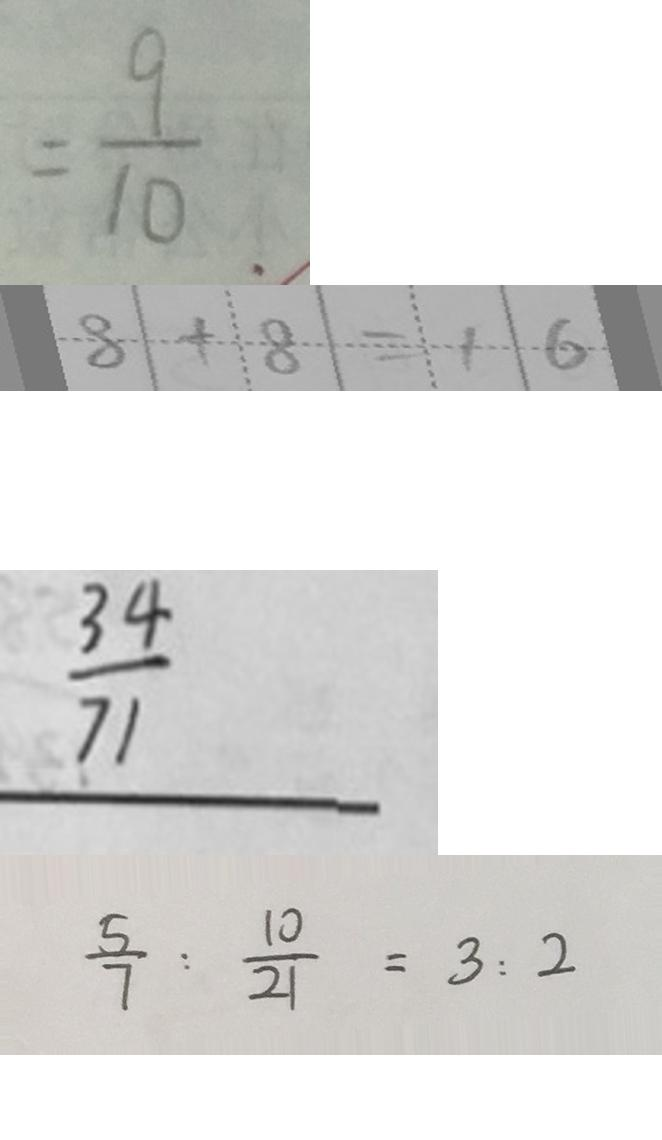<formula> <loc_0><loc_0><loc_500><loc_500>= \frac { 9 } { 1 0 } 
 8 + 8 = 1 6 
 \frac { 3 4 } { 1 7 } 
 \frac { 5 } { 7 } : \frac { 1 0 } { 2 1 } = 3 : 2</formula> 